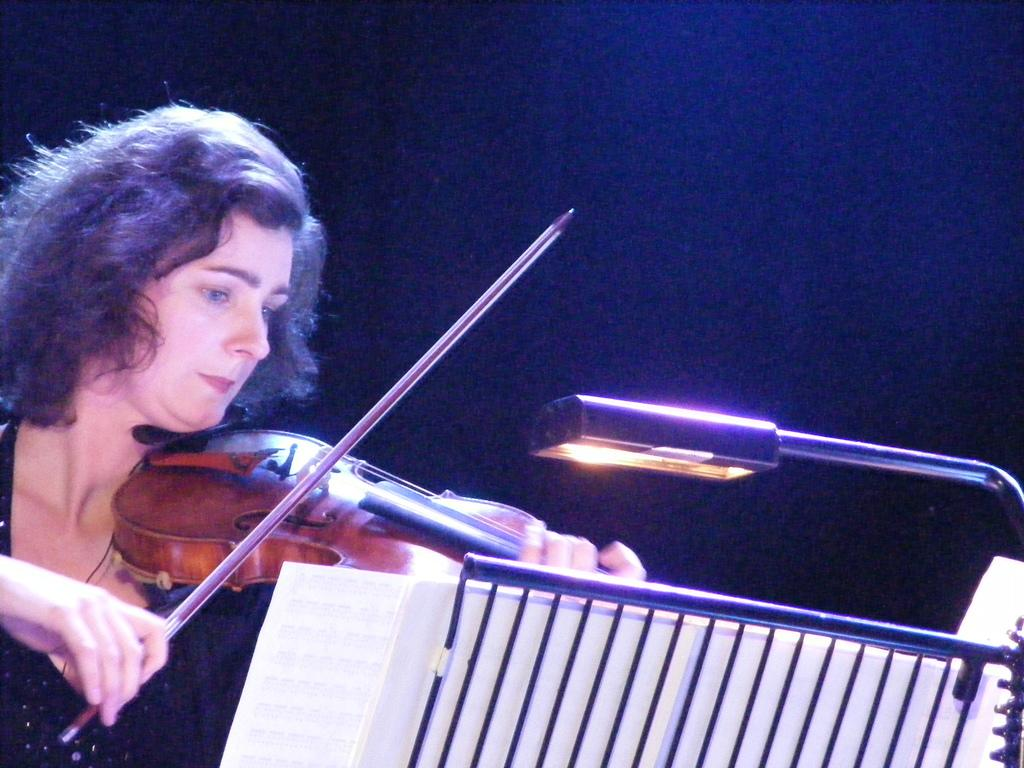Who is present in the image? There is a woman in the image. What is the woman holding in the image? The woman is holding a musical instrument. What type of lighting is present in the image? There is a lamp in the image. What is the purpose of the stand in the image? The stand is likely used to support the musical instrument. What type of mist can be seen surrounding the woman in the image? There is no mist present in the image; it is a clear scene with the woman holding a musical instrument. 